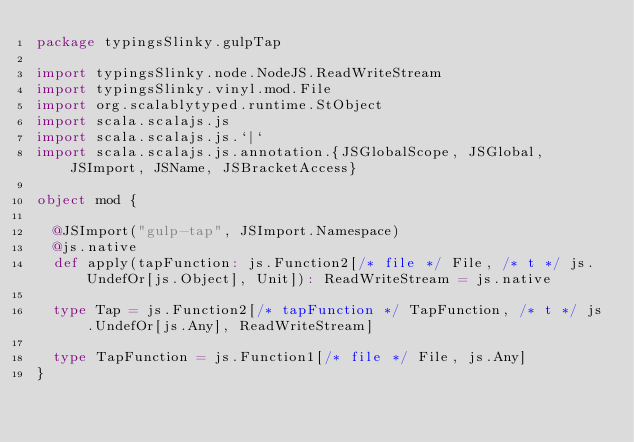Convert code to text. <code><loc_0><loc_0><loc_500><loc_500><_Scala_>package typingsSlinky.gulpTap

import typingsSlinky.node.NodeJS.ReadWriteStream
import typingsSlinky.vinyl.mod.File
import org.scalablytyped.runtime.StObject
import scala.scalajs.js
import scala.scalajs.js.`|`
import scala.scalajs.js.annotation.{JSGlobalScope, JSGlobal, JSImport, JSName, JSBracketAccess}

object mod {
  
  @JSImport("gulp-tap", JSImport.Namespace)
  @js.native
  def apply(tapFunction: js.Function2[/* file */ File, /* t */ js.UndefOr[js.Object], Unit]): ReadWriteStream = js.native
  
  type Tap = js.Function2[/* tapFunction */ TapFunction, /* t */ js.UndefOr[js.Any], ReadWriteStream]
  
  type TapFunction = js.Function1[/* file */ File, js.Any]
}
</code> 